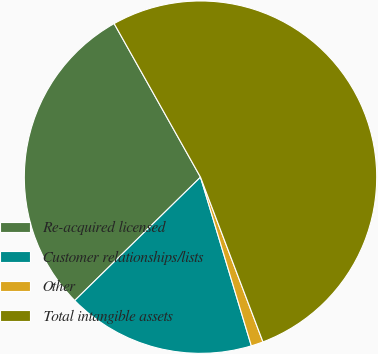Convert chart to OTSL. <chart><loc_0><loc_0><loc_500><loc_500><pie_chart><fcel>Re-acquired licensed<fcel>Customer relationships/lists<fcel>Other<fcel>Total intangible assets<nl><fcel>29.19%<fcel>17.31%<fcel>1.11%<fcel>52.38%<nl></chart> 